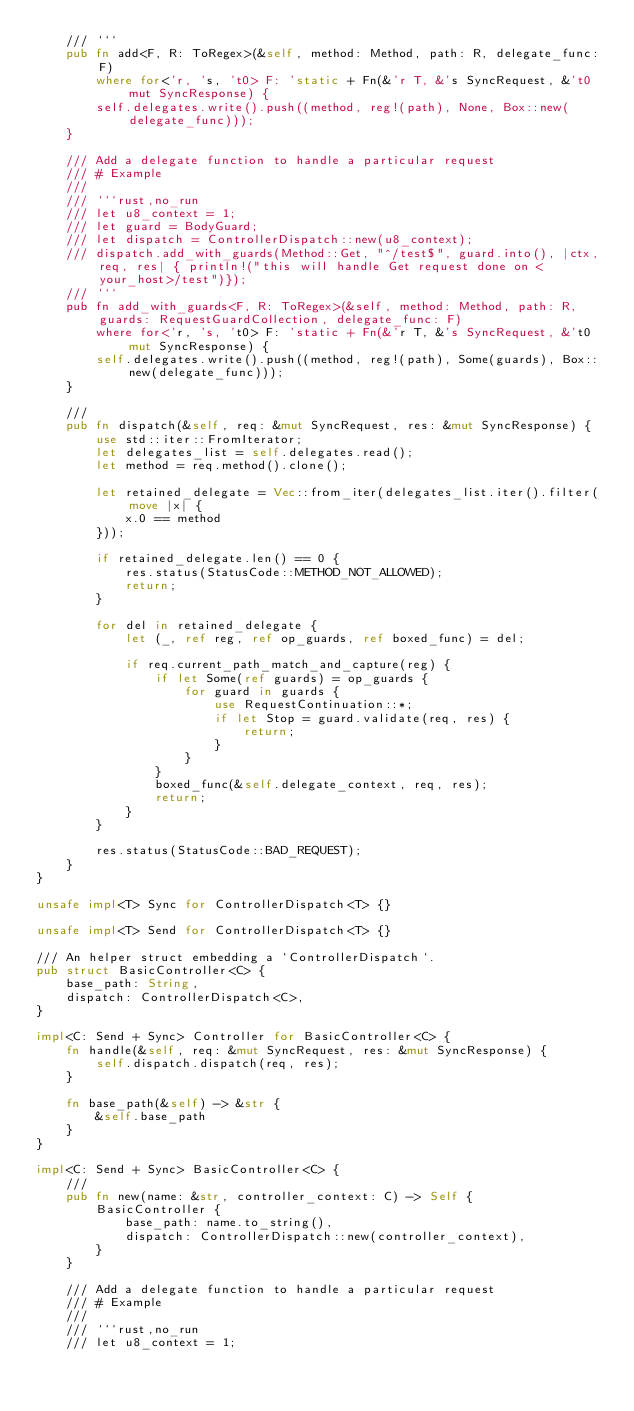Convert code to text. <code><loc_0><loc_0><loc_500><loc_500><_Rust_>    /// ```
    pub fn add<F, R: ToRegex>(&self, method: Method, path: R, delegate_func: F)
        where for<'r, 's, 't0> F: 'static + Fn(&'r T, &'s SyncRequest, &'t0 mut SyncResponse) {
        self.delegates.write().push((method, reg!(path), None, Box::new(delegate_func)));
    }

    /// Add a delegate function to handle a particular request
    /// # Example
    ///
    /// ```rust,no_run
    /// let u8_context = 1;
    /// let guard = BodyGuard;
    /// let dispatch = ControllerDispatch::new(u8_context);
    /// dispatch.add_with_guards(Method::Get, "^/test$", guard.into(), |ctx, req, res| { println!("this will handle Get request done on <your_host>/test")});
    /// ```
    pub fn add_with_guards<F, R: ToRegex>(&self, method: Method, path: R, guards: RequestGuardCollection, delegate_func: F)
        where for<'r, 's, 't0> F: 'static + Fn(&'r T, &'s SyncRequest, &'t0 mut SyncResponse) {
        self.delegates.write().push((method, reg!(path), Some(guards), Box::new(delegate_func)));
    }

    ///
    pub fn dispatch(&self, req: &mut SyncRequest, res: &mut SyncResponse) {
        use std::iter::FromIterator;
        let delegates_list = self.delegates.read();
        let method = req.method().clone();

        let retained_delegate = Vec::from_iter(delegates_list.iter().filter(move |x| {
            x.0 == method
        }));

        if retained_delegate.len() == 0 {
            res.status(StatusCode::METHOD_NOT_ALLOWED);
            return;
        }

        for del in retained_delegate {
            let (_, ref reg, ref op_guards, ref boxed_func) = del;

            if req.current_path_match_and_capture(reg) {
                if let Some(ref guards) = op_guards {
                    for guard in guards {
                        use RequestContinuation::*;
                        if let Stop = guard.validate(req, res) {
                            return;
                        }
                    }
                }
                boxed_func(&self.delegate_context, req, res);
                return;
            }
        }

        res.status(StatusCode::BAD_REQUEST);
    }
}

unsafe impl<T> Sync for ControllerDispatch<T> {}

unsafe impl<T> Send for ControllerDispatch<T> {}

/// An helper struct embedding a `ControllerDispatch`.
pub struct BasicController<C> {
    base_path: String,
    dispatch: ControllerDispatch<C>,
}

impl<C: Send + Sync> Controller for BasicController<C> {
    fn handle(&self, req: &mut SyncRequest, res: &mut SyncResponse) {
        self.dispatch.dispatch(req, res);
    }

    fn base_path(&self) -> &str {
        &self.base_path
    }
}

impl<C: Send + Sync> BasicController<C> {
    ///
    pub fn new(name: &str, controller_context: C) -> Self {
        BasicController {
            base_path: name.to_string(),
            dispatch: ControllerDispatch::new(controller_context),
        }
    }

    /// Add a delegate function to handle a particular request
    /// # Example
    ///
    /// ```rust,no_run
    /// let u8_context = 1;</code> 